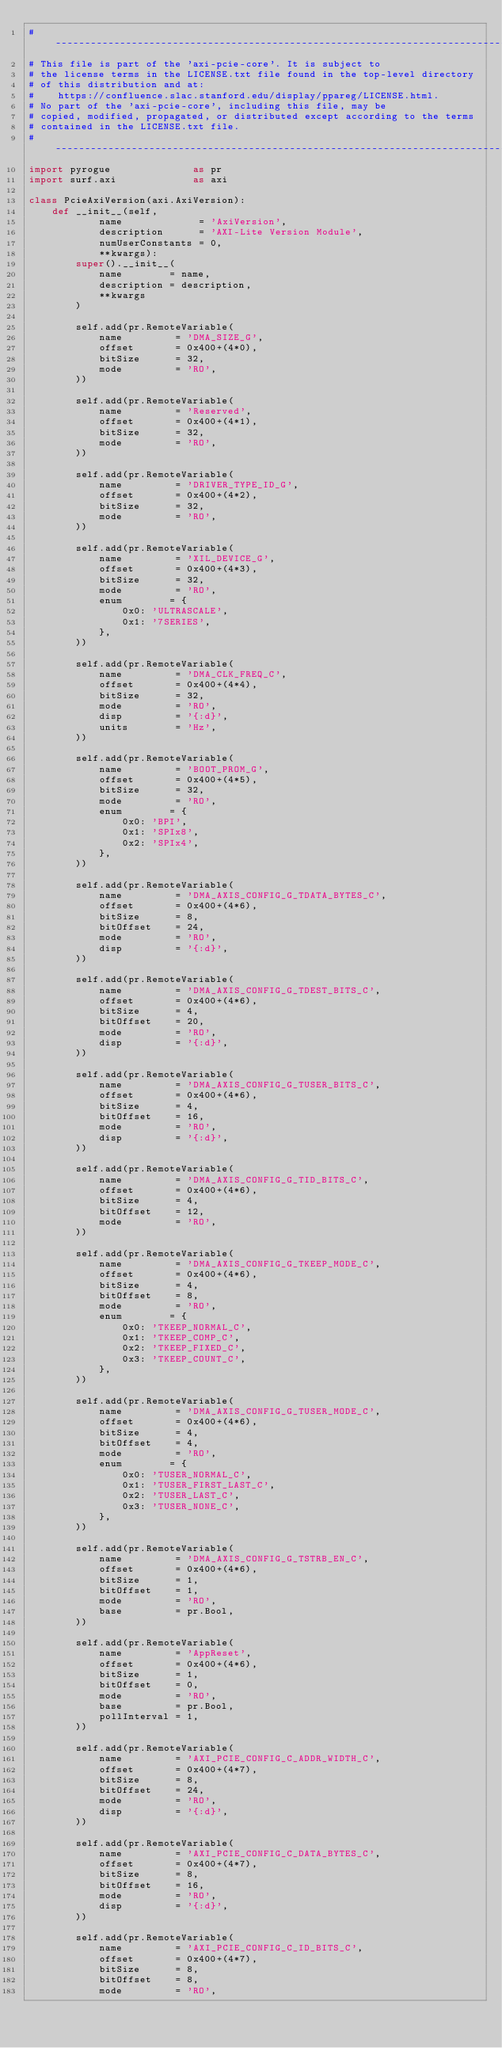Convert code to text. <code><loc_0><loc_0><loc_500><loc_500><_Python_>#-----------------------------------------------------------------------------
# This file is part of the 'axi-pcie-core'. It is subject to
# the license terms in the LICENSE.txt file found in the top-level directory
# of this distribution and at:
#    https://confluence.slac.stanford.edu/display/ppareg/LICENSE.html.
# No part of the 'axi-pcie-core', including this file, may be
# copied, modified, propagated, or distributed except according to the terms
# contained in the LICENSE.txt file.
#-----------------------------------------------------------------------------
import pyrogue              as pr
import surf.axi             as axi

class PcieAxiVersion(axi.AxiVersion):
    def __init__(self,
            name             = 'AxiVersion',
            description      = 'AXI-Lite Version Module',
            numUserConstants = 0,
            **kwargs):
        super().__init__(
            name        = name,
            description = description,
            **kwargs
        )

        self.add(pr.RemoteVariable(
            name         = 'DMA_SIZE_G',
            offset       = 0x400+(4*0),
            bitSize      = 32,
            mode         = 'RO',
        ))

        self.add(pr.RemoteVariable(
            name         = 'Reserved',
            offset       = 0x400+(4*1),
            bitSize      = 32,
            mode         = 'RO',
        ))

        self.add(pr.RemoteVariable(
            name         = 'DRIVER_TYPE_ID_G',
            offset       = 0x400+(4*2),
            bitSize      = 32,
            mode         = 'RO',
        ))

        self.add(pr.RemoteVariable(
            name         = 'XIL_DEVICE_G',
            offset       = 0x400+(4*3),
            bitSize      = 32,
            mode         = 'RO',
            enum        = {
                0x0: 'ULTRASCALE',
                0x1: '7SERIES',
            },
        ))

        self.add(pr.RemoteVariable(
            name         = 'DMA_CLK_FREQ_C',
            offset       = 0x400+(4*4),
            bitSize      = 32,
            mode         = 'RO',
            disp         = '{:d}',
            units        = 'Hz',
        ))

        self.add(pr.RemoteVariable(
            name         = 'BOOT_PROM_G',
            offset       = 0x400+(4*5),
            bitSize      = 32,
            mode         = 'RO',
            enum        = {
                0x0: 'BPI',
                0x1: 'SPIx8',
                0x2: 'SPIx4',
            },
        ))

        self.add(pr.RemoteVariable(
            name         = 'DMA_AXIS_CONFIG_G_TDATA_BYTES_C',
            offset       = 0x400+(4*6),
            bitSize      = 8,
            bitOffset    = 24,
            mode         = 'RO',
            disp         = '{:d}',
        ))

        self.add(pr.RemoteVariable(
            name         = 'DMA_AXIS_CONFIG_G_TDEST_BITS_C',
            offset       = 0x400+(4*6),
            bitSize      = 4,
            bitOffset    = 20,
            mode         = 'RO',
            disp         = '{:d}',
        ))

        self.add(pr.RemoteVariable(
            name         = 'DMA_AXIS_CONFIG_G_TUSER_BITS_C',
            offset       = 0x400+(4*6),
            bitSize      = 4,
            bitOffset    = 16,
            mode         = 'RO',
            disp         = '{:d}',
        ))

        self.add(pr.RemoteVariable(
            name         = 'DMA_AXIS_CONFIG_G_TID_BITS_C',
            offset       = 0x400+(4*6),
            bitSize      = 4,
            bitOffset    = 12,
            mode         = 'RO',
        ))

        self.add(pr.RemoteVariable(
            name         = 'DMA_AXIS_CONFIG_G_TKEEP_MODE_C',
            offset       = 0x400+(4*6),
            bitSize      = 4,
            bitOffset    = 8,
            mode         = 'RO',
            enum        = {
                0x0: 'TKEEP_NORMAL_C',
                0x1: 'TKEEP_COMP_C',
                0x2: 'TKEEP_FIXED_C',
                0x3: 'TKEEP_COUNT_C',
            },
        ))

        self.add(pr.RemoteVariable(
            name         = 'DMA_AXIS_CONFIG_G_TUSER_MODE_C',
            offset       = 0x400+(4*6),
            bitSize      = 4,
            bitOffset    = 4,
            mode         = 'RO',
            enum        = {
                0x0: 'TUSER_NORMAL_C',
                0x1: 'TUSER_FIRST_LAST_C',
                0x2: 'TUSER_LAST_C',
                0x3: 'TUSER_NONE_C',
            },
        ))

        self.add(pr.RemoteVariable(
            name         = 'DMA_AXIS_CONFIG_G_TSTRB_EN_C',
            offset       = 0x400+(4*6),
            bitSize      = 1,
            bitOffset    = 1,
            mode         = 'RO',
            base         = pr.Bool,
        ))

        self.add(pr.RemoteVariable(
            name         = 'AppReset',
            offset       = 0x400+(4*6),
            bitSize      = 1,
            bitOffset    = 0,
            mode         = 'RO',
            base         = pr.Bool,
            pollInterval = 1,
        ))

        self.add(pr.RemoteVariable(
            name         = 'AXI_PCIE_CONFIG_C_ADDR_WIDTH_C',
            offset       = 0x400+(4*7),
            bitSize      = 8,
            bitOffset    = 24,
            mode         = 'RO',
            disp         = '{:d}',
        ))

        self.add(pr.RemoteVariable(
            name         = 'AXI_PCIE_CONFIG_C_DATA_BYTES_C',
            offset       = 0x400+(4*7),
            bitSize      = 8,
            bitOffset    = 16,
            mode         = 'RO',
            disp         = '{:d}',
        ))

        self.add(pr.RemoteVariable(
            name         = 'AXI_PCIE_CONFIG_C_ID_BITS_C',
            offset       = 0x400+(4*7),
            bitSize      = 8,
            bitOffset    = 8,
            mode         = 'RO',</code> 